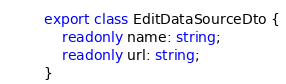Convert code to text. <code><loc_0><loc_0><loc_500><loc_500><_TypeScript_>export class EditDataSourceDto {
	readonly name: string;
	readonly url: string;
}
</code> 